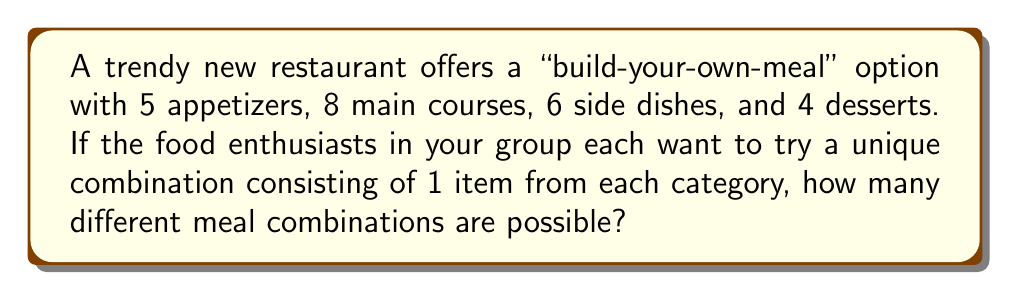Can you solve this math problem? Let's approach this step-by-step using the multiplication principle of counting:

1) For each meal combination, we need to choose:
   - 1 appetizer out of 5
   - 1 main course out of 8
   - 1 side dish out of 6
   - 1 dessert out of 4

2) The multiplication principle states that if we have a sequence of $n$ independent choices, where:
   - the 1st choice has $m_1$ options
   - the 2nd choice has $m_2$ options
   - ...
   - the $n$th choice has $m_n$ options

   Then the total number of possible outcomes is:

   $$m_1 \times m_2 \times ... \times m_n$$

3) In our case:
   - Number of appetizer choices: $m_1 = 5$
   - Number of main course choices: $m_2 = 8$
   - Number of side dish choices: $m_3 = 6$
   - Number of dessert choices: $m_4 = 4$

4) Applying the multiplication principle:

   Total combinations $= 5 \times 8 \times 6 \times 4$

5) Calculating:
   $$5 \times 8 \times 6 \times 4 = 40 \times 24 = 960$$

Therefore, there are 960 unique meal combinations possible.
Answer: 960 